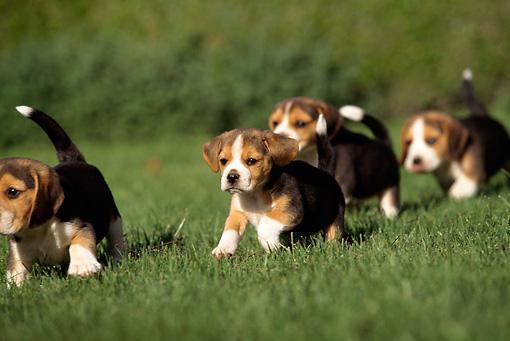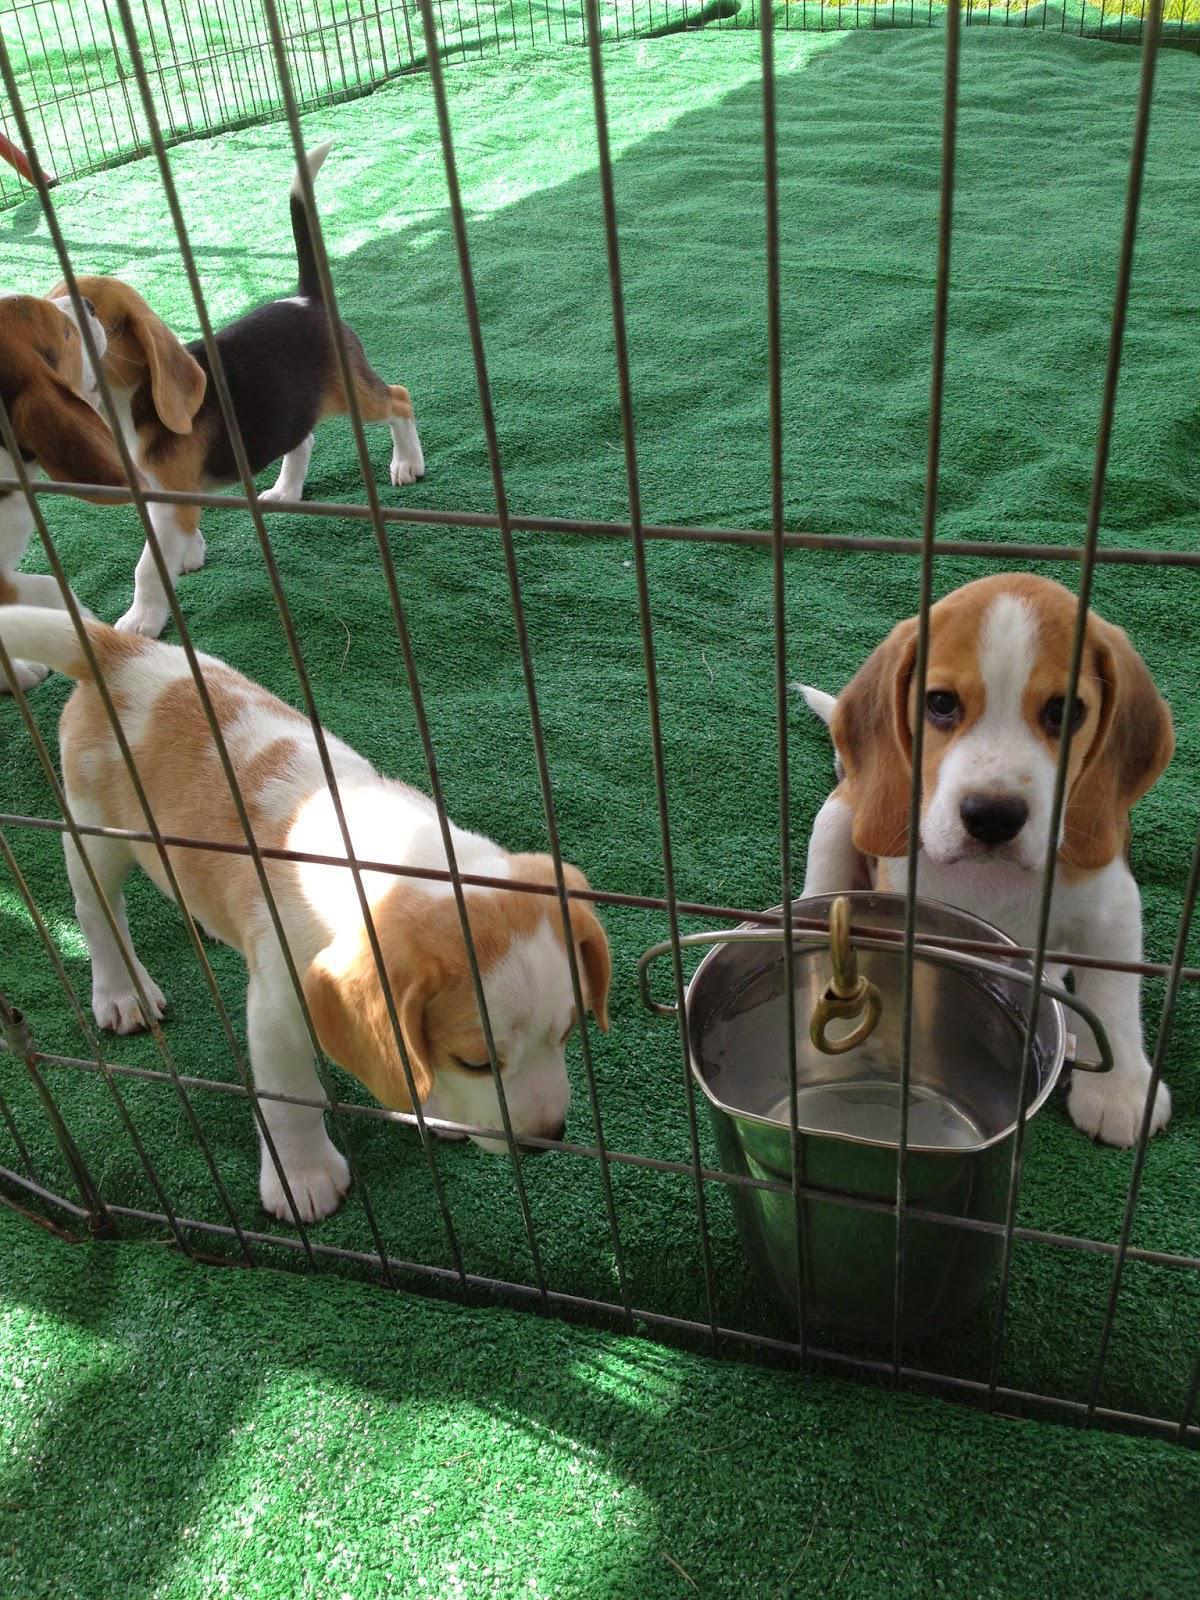The first image is the image on the left, the second image is the image on the right. For the images displayed, is the sentence "One image shows a man in a hat leading a pack of dogs down a paved country lane." factually correct? Answer yes or no. No. 